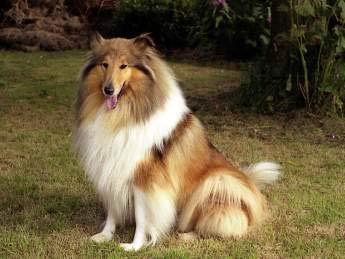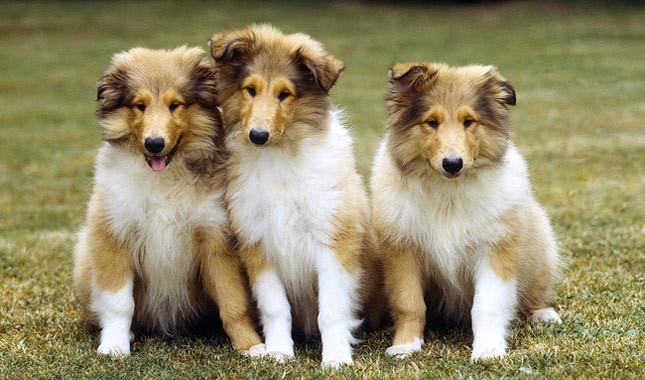The first image is the image on the left, the second image is the image on the right. Evaluate the accuracy of this statement regarding the images: "The dogs on the left are running.". Is it true? Answer yes or no. No. 